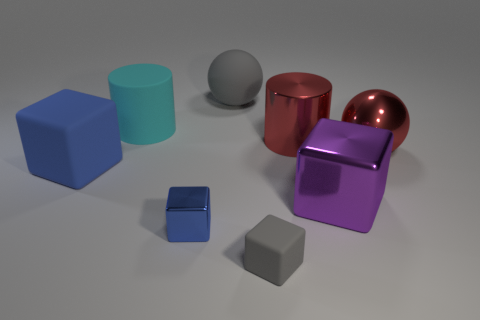Can you tell me the different shapes and colors in the image? Certainly! In the image, we see several 3D geometric shapes. There's a blue cube, a teal cylinder, a gray sphere, a red metallic cylinder with a reflective surface, and two smaller purple and blue cubes, alongside a small gray hexagonal prism. Each shape has a distinct color and reflects light differently, indicating diverse textures and materials. 